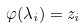Convert formula to latex. <formula><loc_0><loc_0><loc_500><loc_500>\varphi ( \lambda _ { i } ) = z _ { i }</formula> 